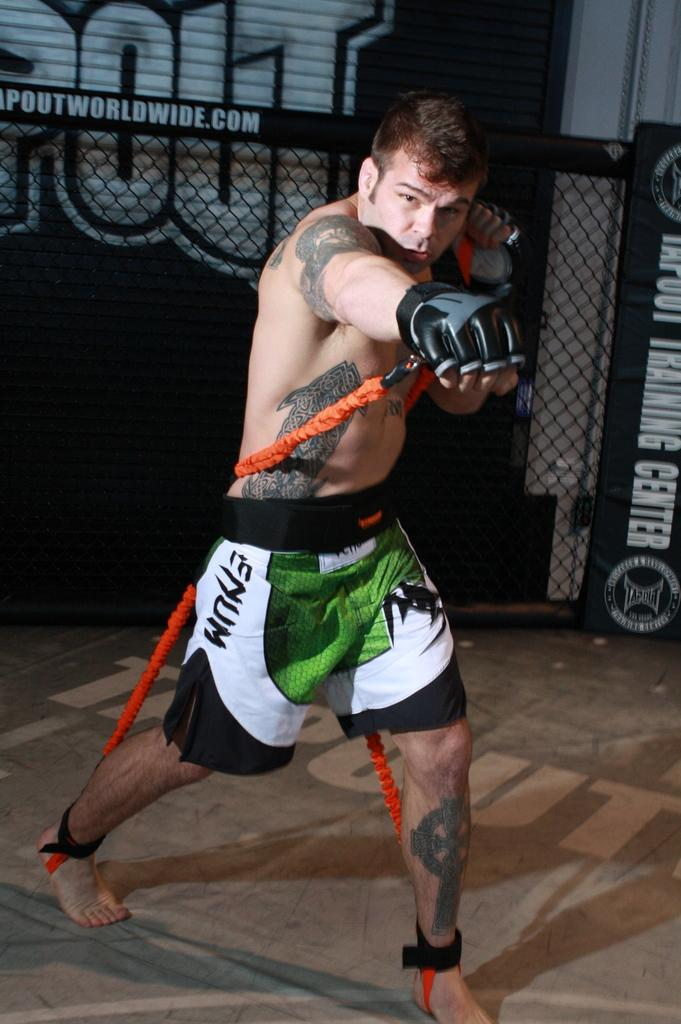<image>
Describe the image concisely. Enum logo on some boxing shorts in a boxing center. 